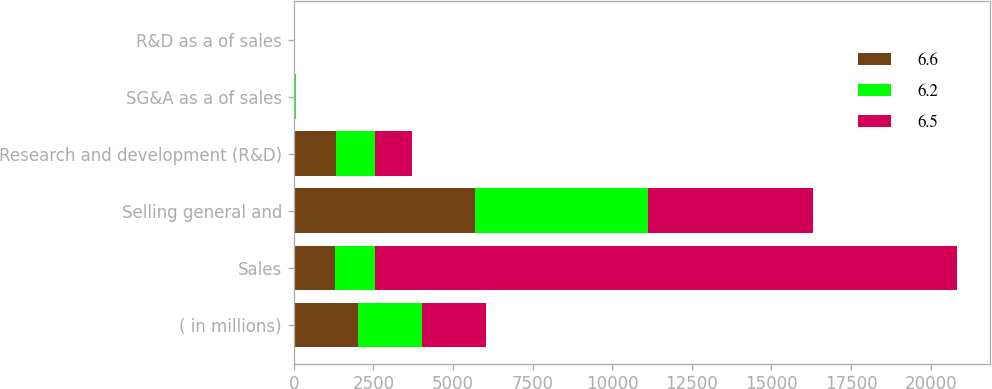<chart> <loc_0><loc_0><loc_500><loc_500><stacked_bar_chart><ecel><fcel>( in millions)<fcel>Sales<fcel>Selling general and<fcel>Research and development (R&D)<fcel>SG&A as a of sales<fcel>R&D as a of sales<nl><fcel>6.6<fcel>2014<fcel>1282.05<fcel>5697<fcel>1314.2<fcel>28.6<fcel>6.6<nl><fcel>6.2<fcel>2013<fcel>1282.05<fcel>5432.8<fcel>1249.9<fcel>28.4<fcel>6.5<nl><fcel>6.5<fcel>2012<fcel>18260.4<fcel>5181.2<fcel>1137.9<fcel>28.4<fcel>6.2<nl></chart> 